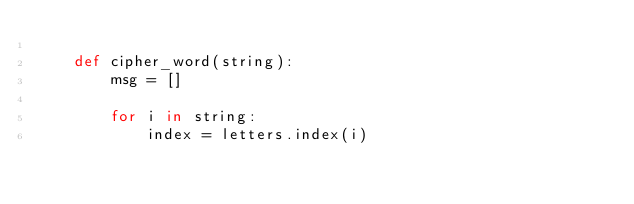Convert code to text. <code><loc_0><loc_0><loc_500><loc_500><_Python_>
    def cipher_word(string):
        msg = []

        for i in string:
            index = letters.index(i)</code> 